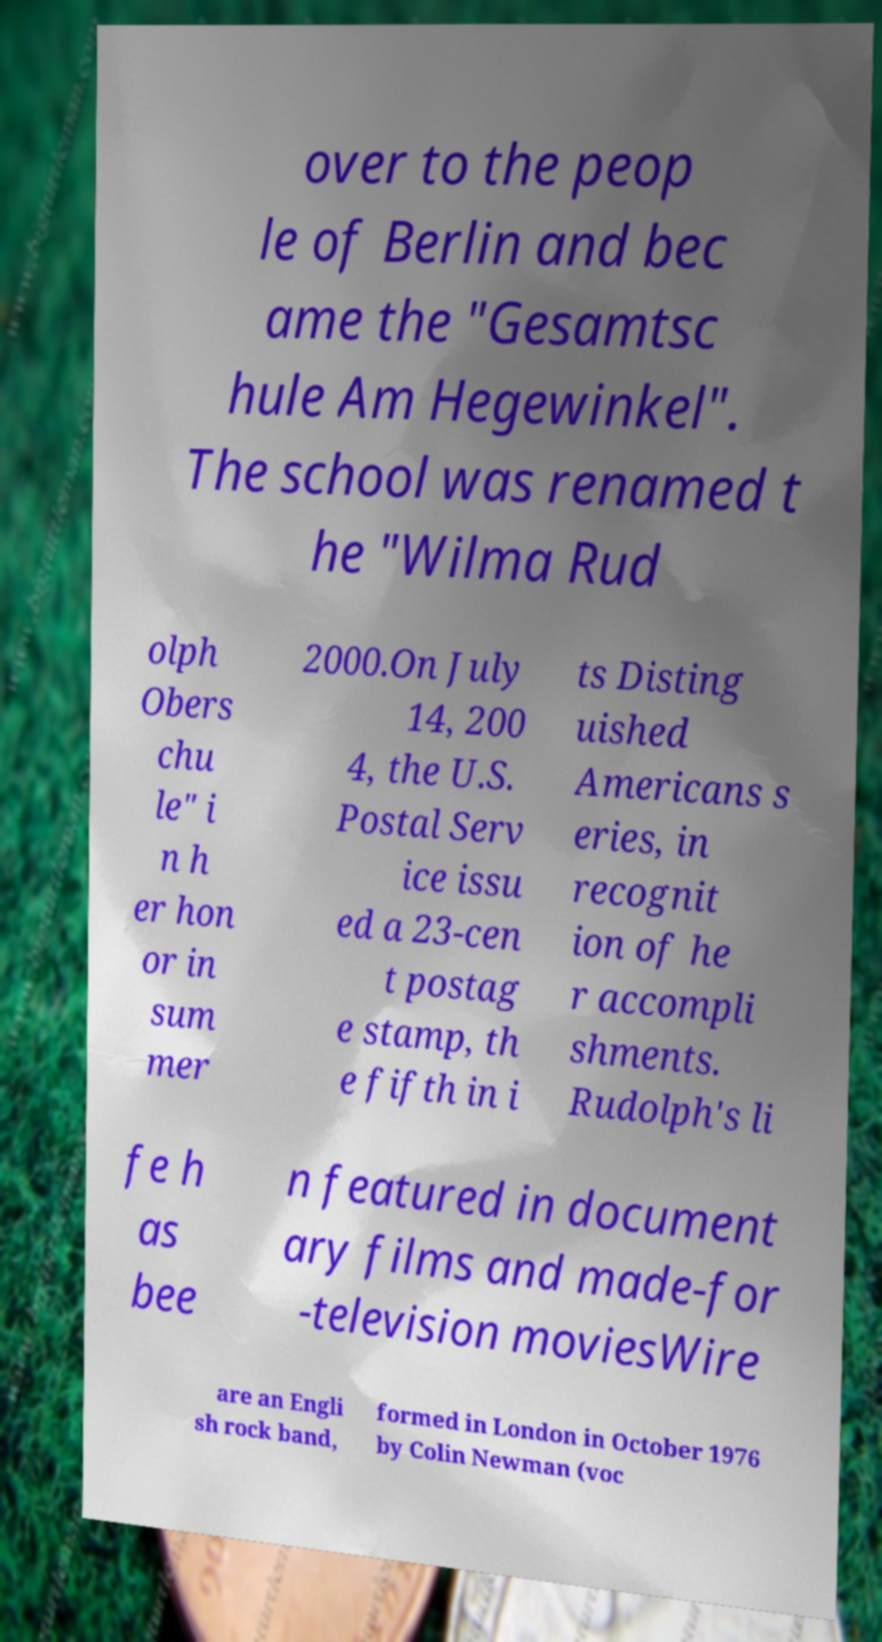Could you extract and type out the text from this image? over to the peop le of Berlin and bec ame the "Gesamtsc hule Am Hegewinkel". The school was renamed t he "Wilma Rud olph Obers chu le" i n h er hon or in sum mer 2000.On July 14, 200 4, the U.S. Postal Serv ice issu ed a 23-cen t postag e stamp, th e fifth in i ts Disting uished Americans s eries, in recognit ion of he r accompli shments. Rudolph's li fe h as bee n featured in document ary films and made-for -television moviesWire are an Engli sh rock band, formed in London in October 1976 by Colin Newman (voc 